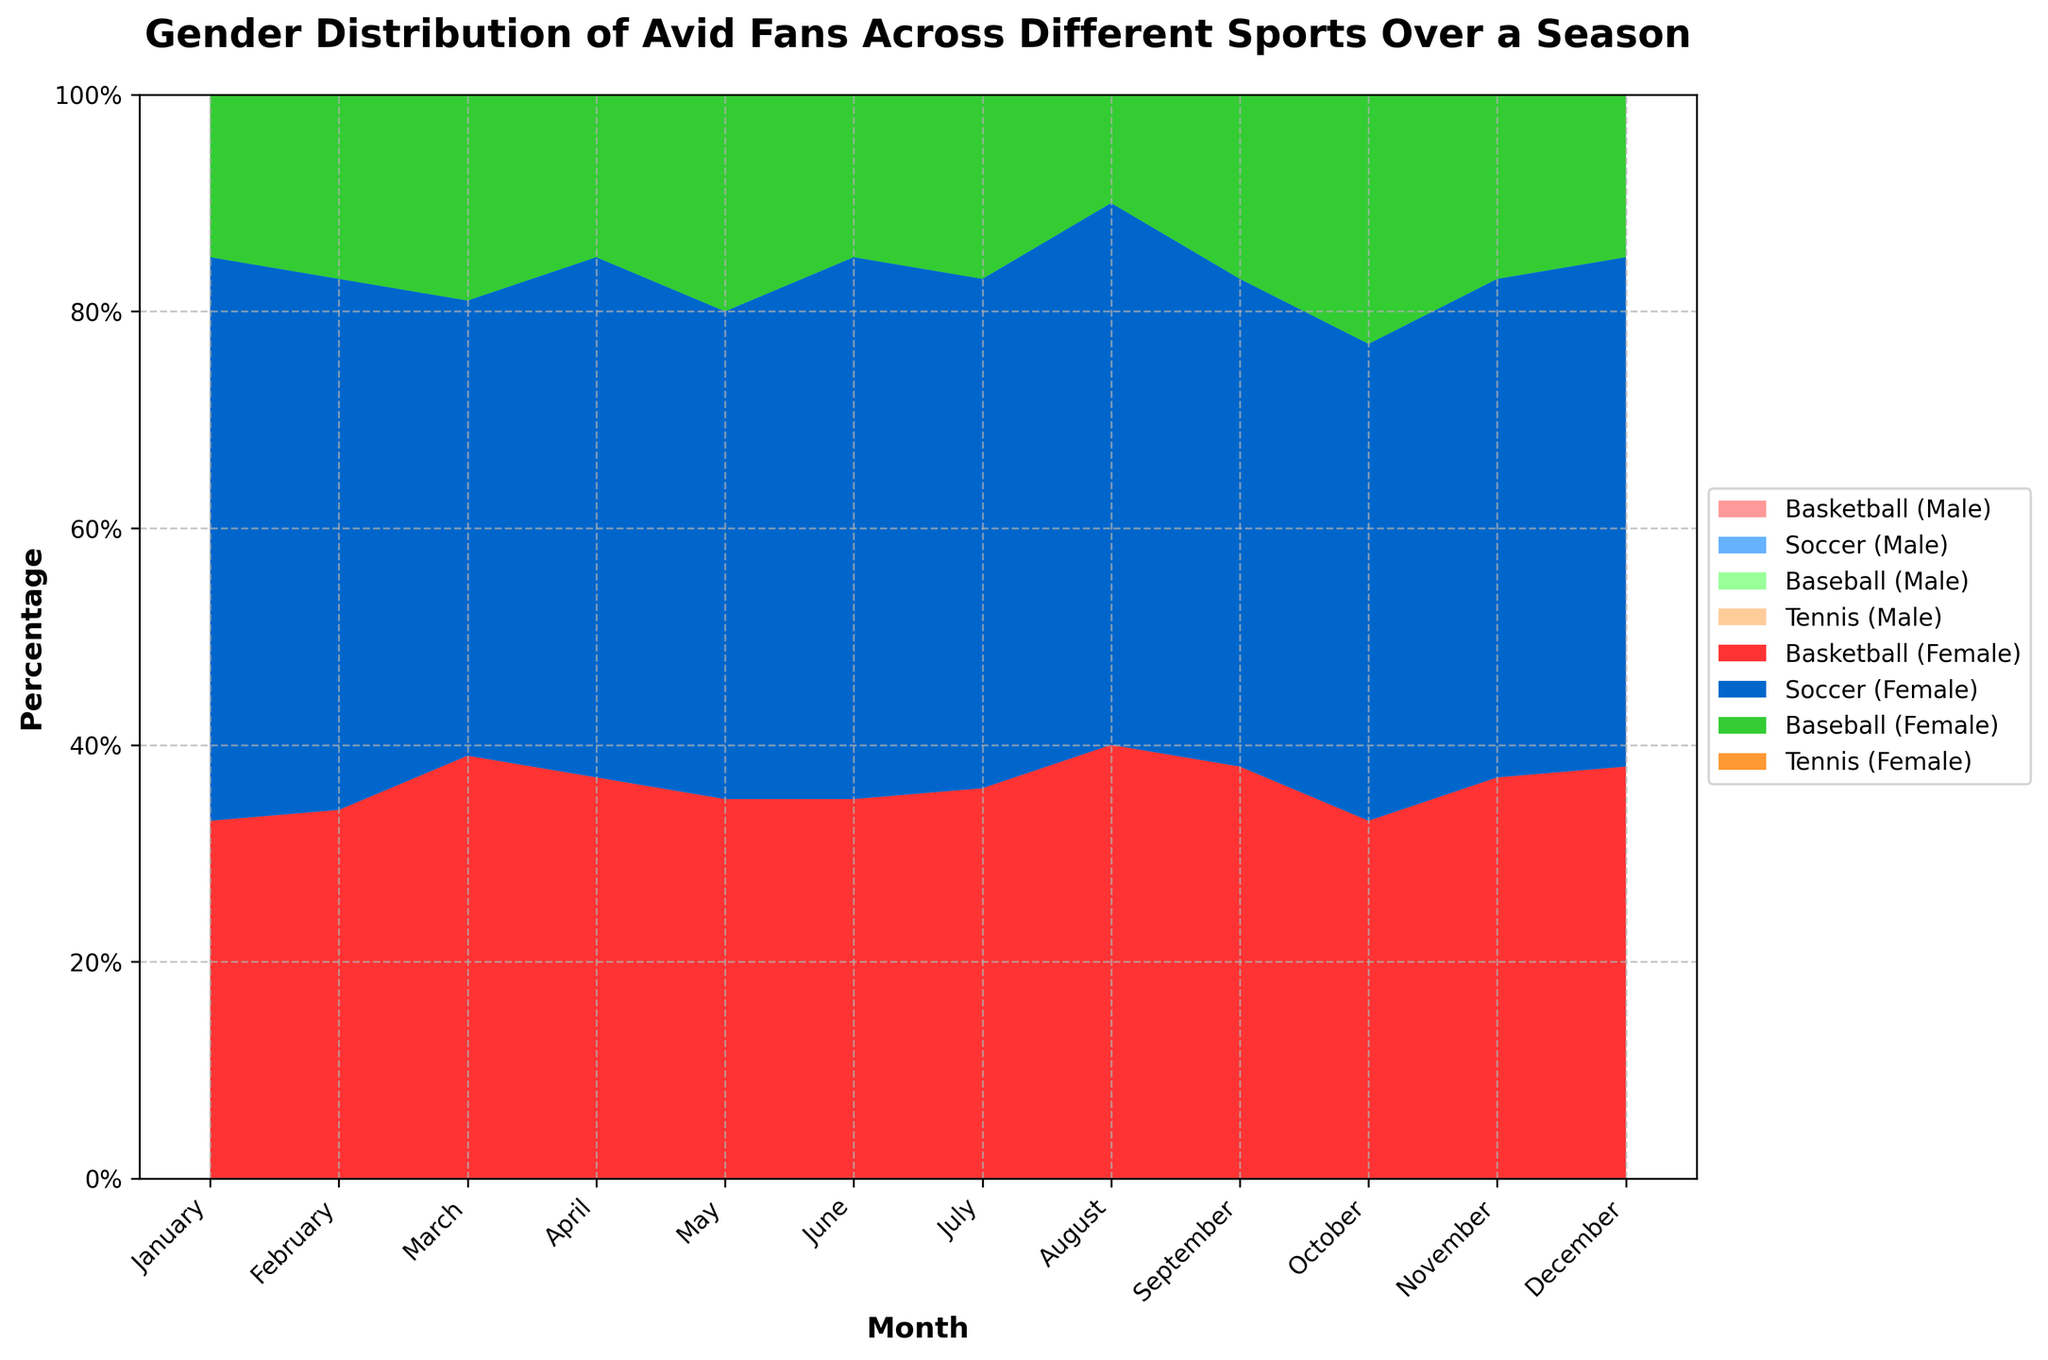What is the title of the chart? The title is written at the top of the chart, which provides an overview of the data being displayed.
Answer: Gender Distribution of Avid Fans Across Different Sports Over a Season How does the percentage of female Tennis fans change over the months? By observing the area corresponding to female Tennis fans, we can see whether it increases, decreases, or remains constant each month. The percentage fluctuates but shows some variations throughout the months.
Answer: It fluctuates Which sport had the highest percentage of male avid fans in December? Look at the male sections for each sport in December, identify which is the tallest among them. Soccer has the highest height in the male section.
Answer: Soccer In which month did Basketball have an equal percentage of male and female fans? Examine the areas for Basketball over the months to find where the male and female areas are equal. This occurs when the Basketball sections for male and female are the same size.
Answer: March and July During which month did Baseball have the greatest difference between male and female fan percentages, and what was the difference? Compare the sizes of the male and female sections for Baseball each month, calculate the differences, and identify the month with the largest difference. The largest difference is in November.
Answer: November, 34% Is there any month where the percentage of male fans was higher for Basketball compared to Soccer? Compare the male sections for Basketball and Soccer month by month to identify any month where Basketball's male area is taller. Some months, male Basketball fans are more than Soccer.
Answer: Yes, in April Which sport generally had the most stable percentage of female fans over the months? Look at the female areas for each sport and visually assess which sport has the least fluctuation in percentage. Tennis shows relatively less fluctuation compared to others.
Answer: Tennis 